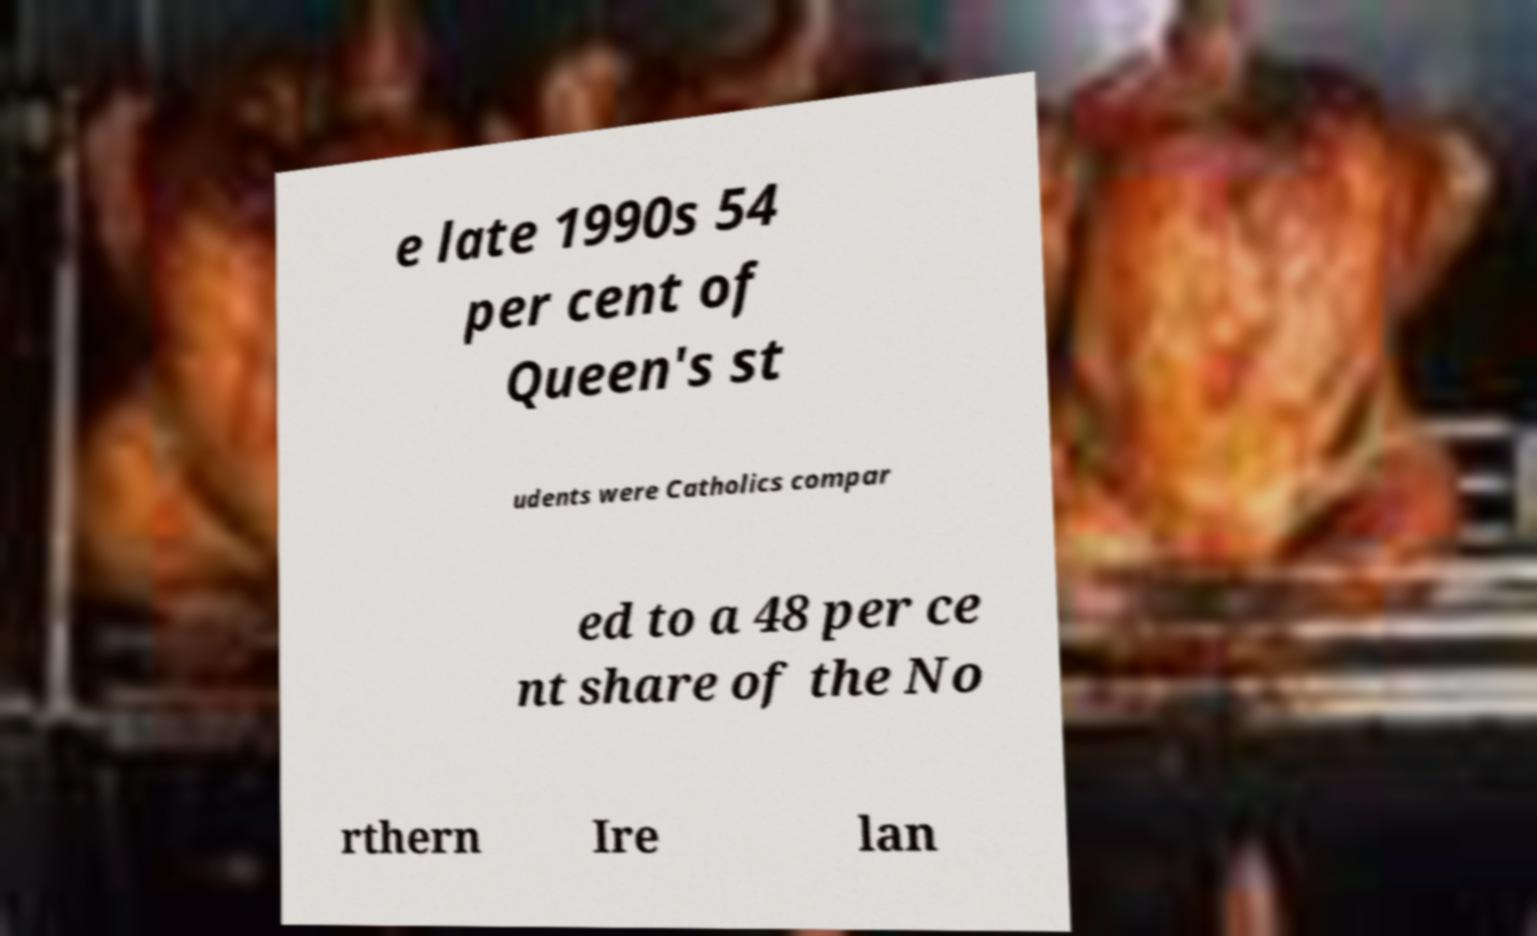Can you accurately transcribe the text from the provided image for me? e late 1990s 54 per cent of Queen's st udents were Catholics compar ed to a 48 per ce nt share of the No rthern Ire lan 